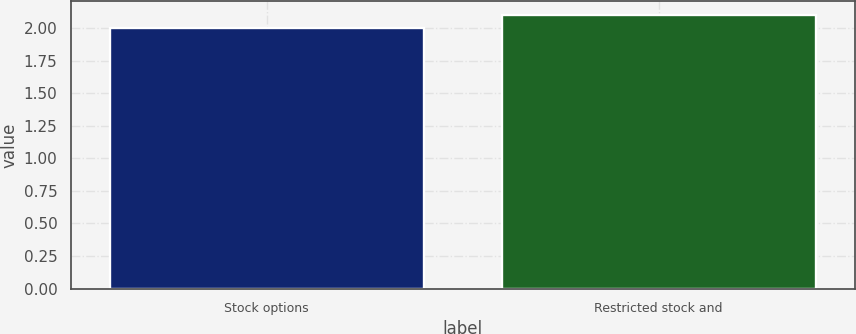Convert chart. <chart><loc_0><loc_0><loc_500><loc_500><bar_chart><fcel>Stock options<fcel>Restricted stock and<nl><fcel>2<fcel>2.1<nl></chart> 